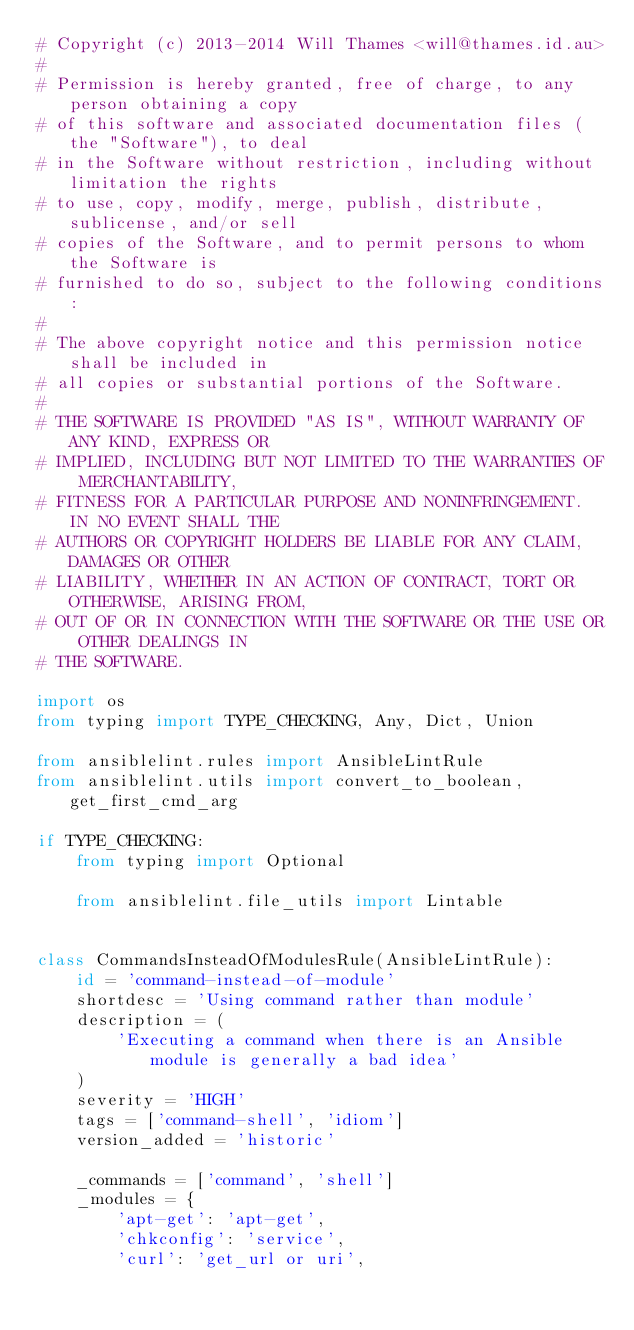Convert code to text. <code><loc_0><loc_0><loc_500><loc_500><_Python_># Copyright (c) 2013-2014 Will Thames <will@thames.id.au>
#
# Permission is hereby granted, free of charge, to any person obtaining a copy
# of this software and associated documentation files (the "Software"), to deal
# in the Software without restriction, including without limitation the rights
# to use, copy, modify, merge, publish, distribute, sublicense, and/or sell
# copies of the Software, and to permit persons to whom the Software is
# furnished to do so, subject to the following conditions:
#
# The above copyright notice and this permission notice shall be included in
# all copies or substantial portions of the Software.
#
# THE SOFTWARE IS PROVIDED "AS IS", WITHOUT WARRANTY OF ANY KIND, EXPRESS OR
# IMPLIED, INCLUDING BUT NOT LIMITED TO THE WARRANTIES OF MERCHANTABILITY,
# FITNESS FOR A PARTICULAR PURPOSE AND NONINFRINGEMENT. IN NO EVENT SHALL THE
# AUTHORS OR COPYRIGHT HOLDERS BE LIABLE FOR ANY CLAIM, DAMAGES OR OTHER
# LIABILITY, WHETHER IN AN ACTION OF CONTRACT, TORT OR OTHERWISE, ARISING FROM,
# OUT OF OR IN CONNECTION WITH THE SOFTWARE OR THE USE OR OTHER DEALINGS IN
# THE SOFTWARE.

import os
from typing import TYPE_CHECKING, Any, Dict, Union

from ansiblelint.rules import AnsibleLintRule
from ansiblelint.utils import convert_to_boolean, get_first_cmd_arg

if TYPE_CHECKING:
    from typing import Optional

    from ansiblelint.file_utils import Lintable


class CommandsInsteadOfModulesRule(AnsibleLintRule):
    id = 'command-instead-of-module'
    shortdesc = 'Using command rather than module'
    description = (
        'Executing a command when there is an Ansible module is generally a bad idea'
    )
    severity = 'HIGH'
    tags = ['command-shell', 'idiom']
    version_added = 'historic'

    _commands = ['command', 'shell']
    _modules = {
        'apt-get': 'apt-get',
        'chkconfig': 'service',
        'curl': 'get_url or uri',</code> 